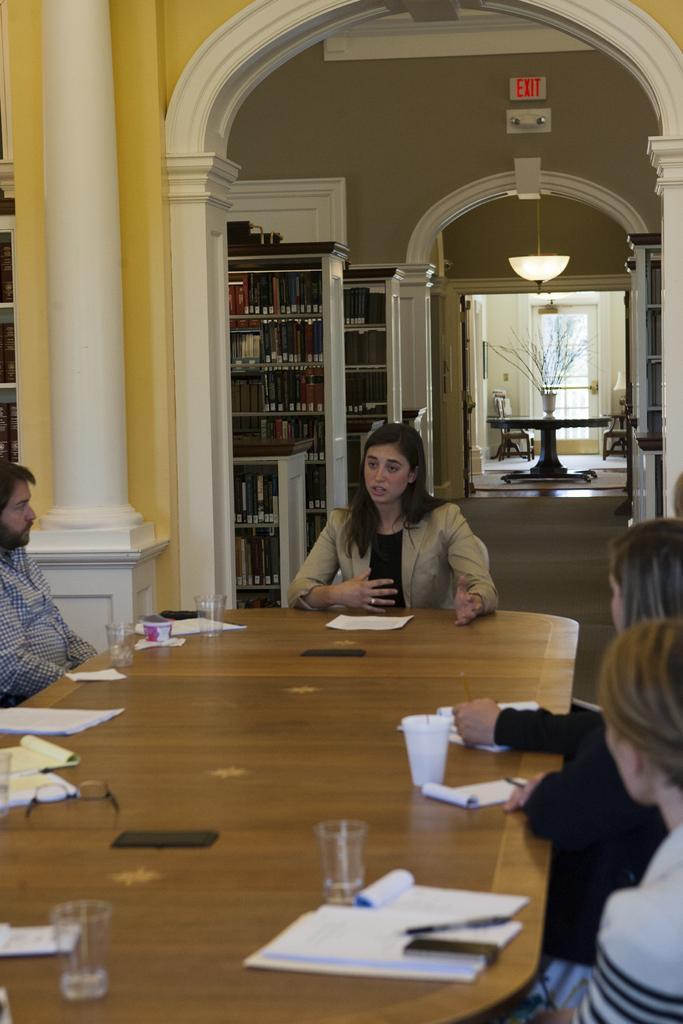Could you give a brief overview of what you see in this image? There are four people sitting on the chairs. This is the table with books,glasses,mobile phones and spectacles placed on it. This is the pillar which is white in color. These are the books which are placed in the book shelf. This a lamp hanging to the rooftop. This is an arch. At background I can see a table with flower vase on it. This is a door. 